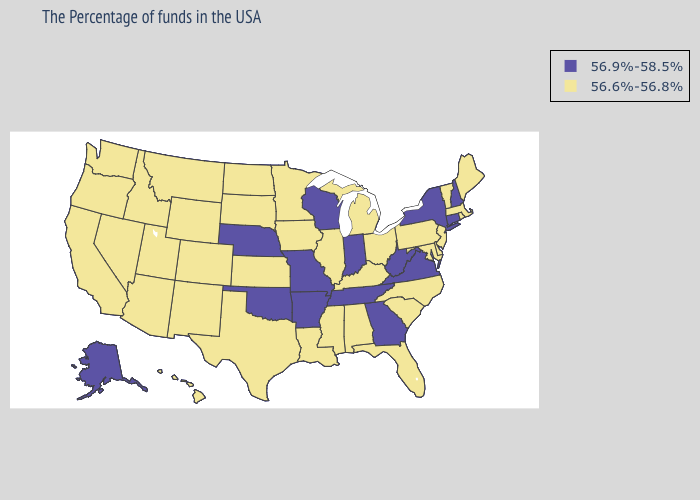Does the first symbol in the legend represent the smallest category?
Keep it brief. No. What is the lowest value in states that border Alabama?
Concise answer only. 56.6%-56.8%. Which states have the lowest value in the South?
Be succinct. Delaware, Maryland, North Carolina, South Carolina, Florida, Kentucky, Alabama, Mississippi, Louisiana, Texas. Name the states that have a value in the range 56.6%-56.8%?
Write a very short answer. Maine, Massachusetts, Rhode Island, Vermont, New Jersey, Delaware, Maryland, Pennsylvania, North Carolina, South Carolina, Ohio, Florida, Michigan, Kentucky, Alabama, Illinois, Mississippi, Louisiana, Minnesota, Iowa, Kansas, Texas, South Dakota, North Dakota, Wyoming, Colorado, New Mexico, Utah, Montana, Arizona, Idaho, Nevada, California, Washington, Oregon, Hawaii. Name the states that have a value in the range 56.9%-58.5%?
Short answer required. New Hampshire, Connecticut, New York, Virginia, West Virginia, Georgia, Indiana, Tennessee, Wisconsin, Missouri, Arkansas, Nebraska, Oklahoma, Alaska. Does the first symbol in the legend represent the smallest category?
Write a very short answer. No. Does Connecticut have the highest value in the USA?
Answer briefly. Yes. What is the value of Vermont?
Keep it brief. 56.6%-56.8%. What is the value of Vermont?
Write a very short answer. 56.6%-56.8%. Does Indiana have the lowest value in the USA?
Short answer required. No. Which states hav the highest value in the Northeast?
Keep it brief. New Hampshire, Connecticut, New York. Does the first symbol in the legend represent the smallest category?
Keep it brief. No. What is the value of Pennsylvania?
Concise answer only. 56.6%-56.8%. Which states have the lowest value in the USA?
Concise answer only. Maine, Massachusetts, Rhode Island, Vermont, New Jersey, Delaware, Maryland, Pennsylvania, North Carolina, South Carolina, Ohio, Florida, Michigan, Kentucky, Alabama, Illinois, Mississippi, Louisiana, Minnesota, Iowa, Kansas, Texas, South Dakota, North Dakota, Wyoming, Colorado, New Mexico, Utah, Montana, Arizona, Idaho, Nevada, California, Washington, Oregon, Hawaii. 